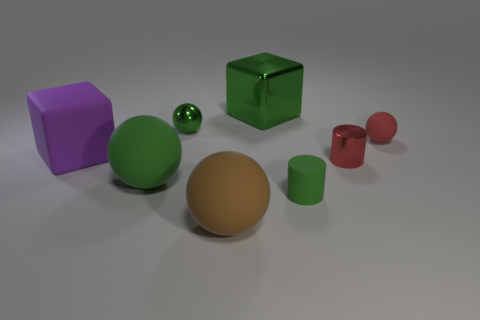Which objects in the image appear to have a matte finish? The brown rubber ball and the violet cube exhibit a matte finish, absorbing light and minimizing reflections, in contrast to the other objects, which have a shiny surface. 